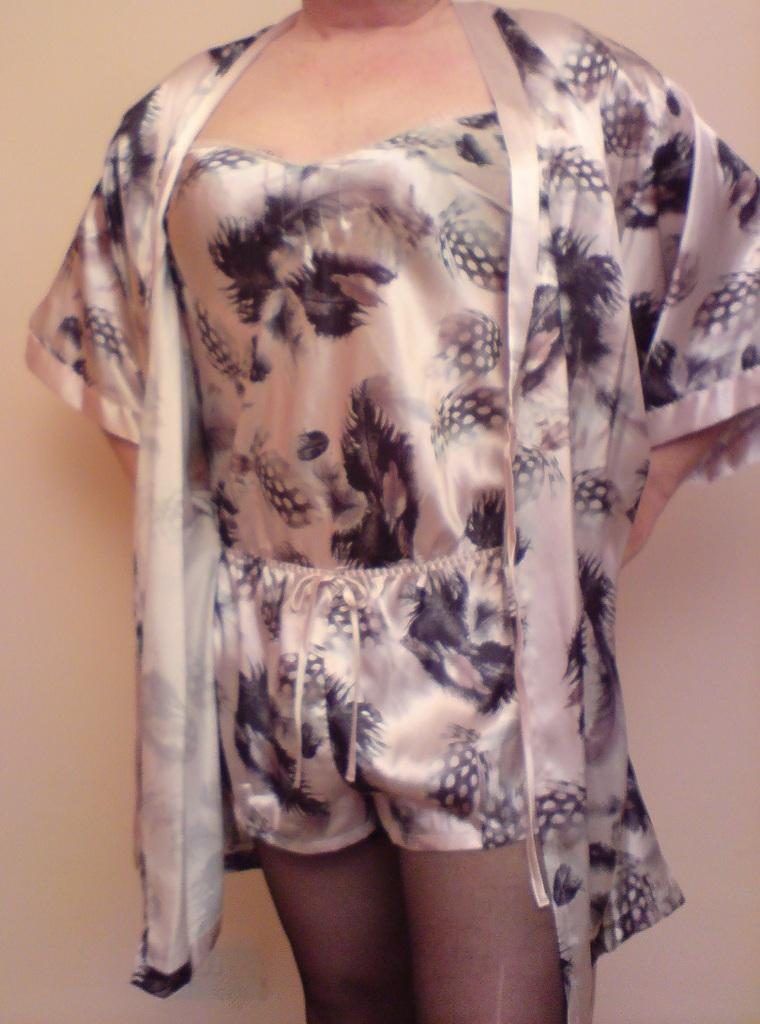What is the main subject of the image? There is a person standing in the image. What is the person wearing? The person is wearing a dress with cream and black colors. What color is the background of the image? The background of the image is cream colored. What type of coast can be seen in the background of the image? There is no coast visible in the image; the background is cream colored. 